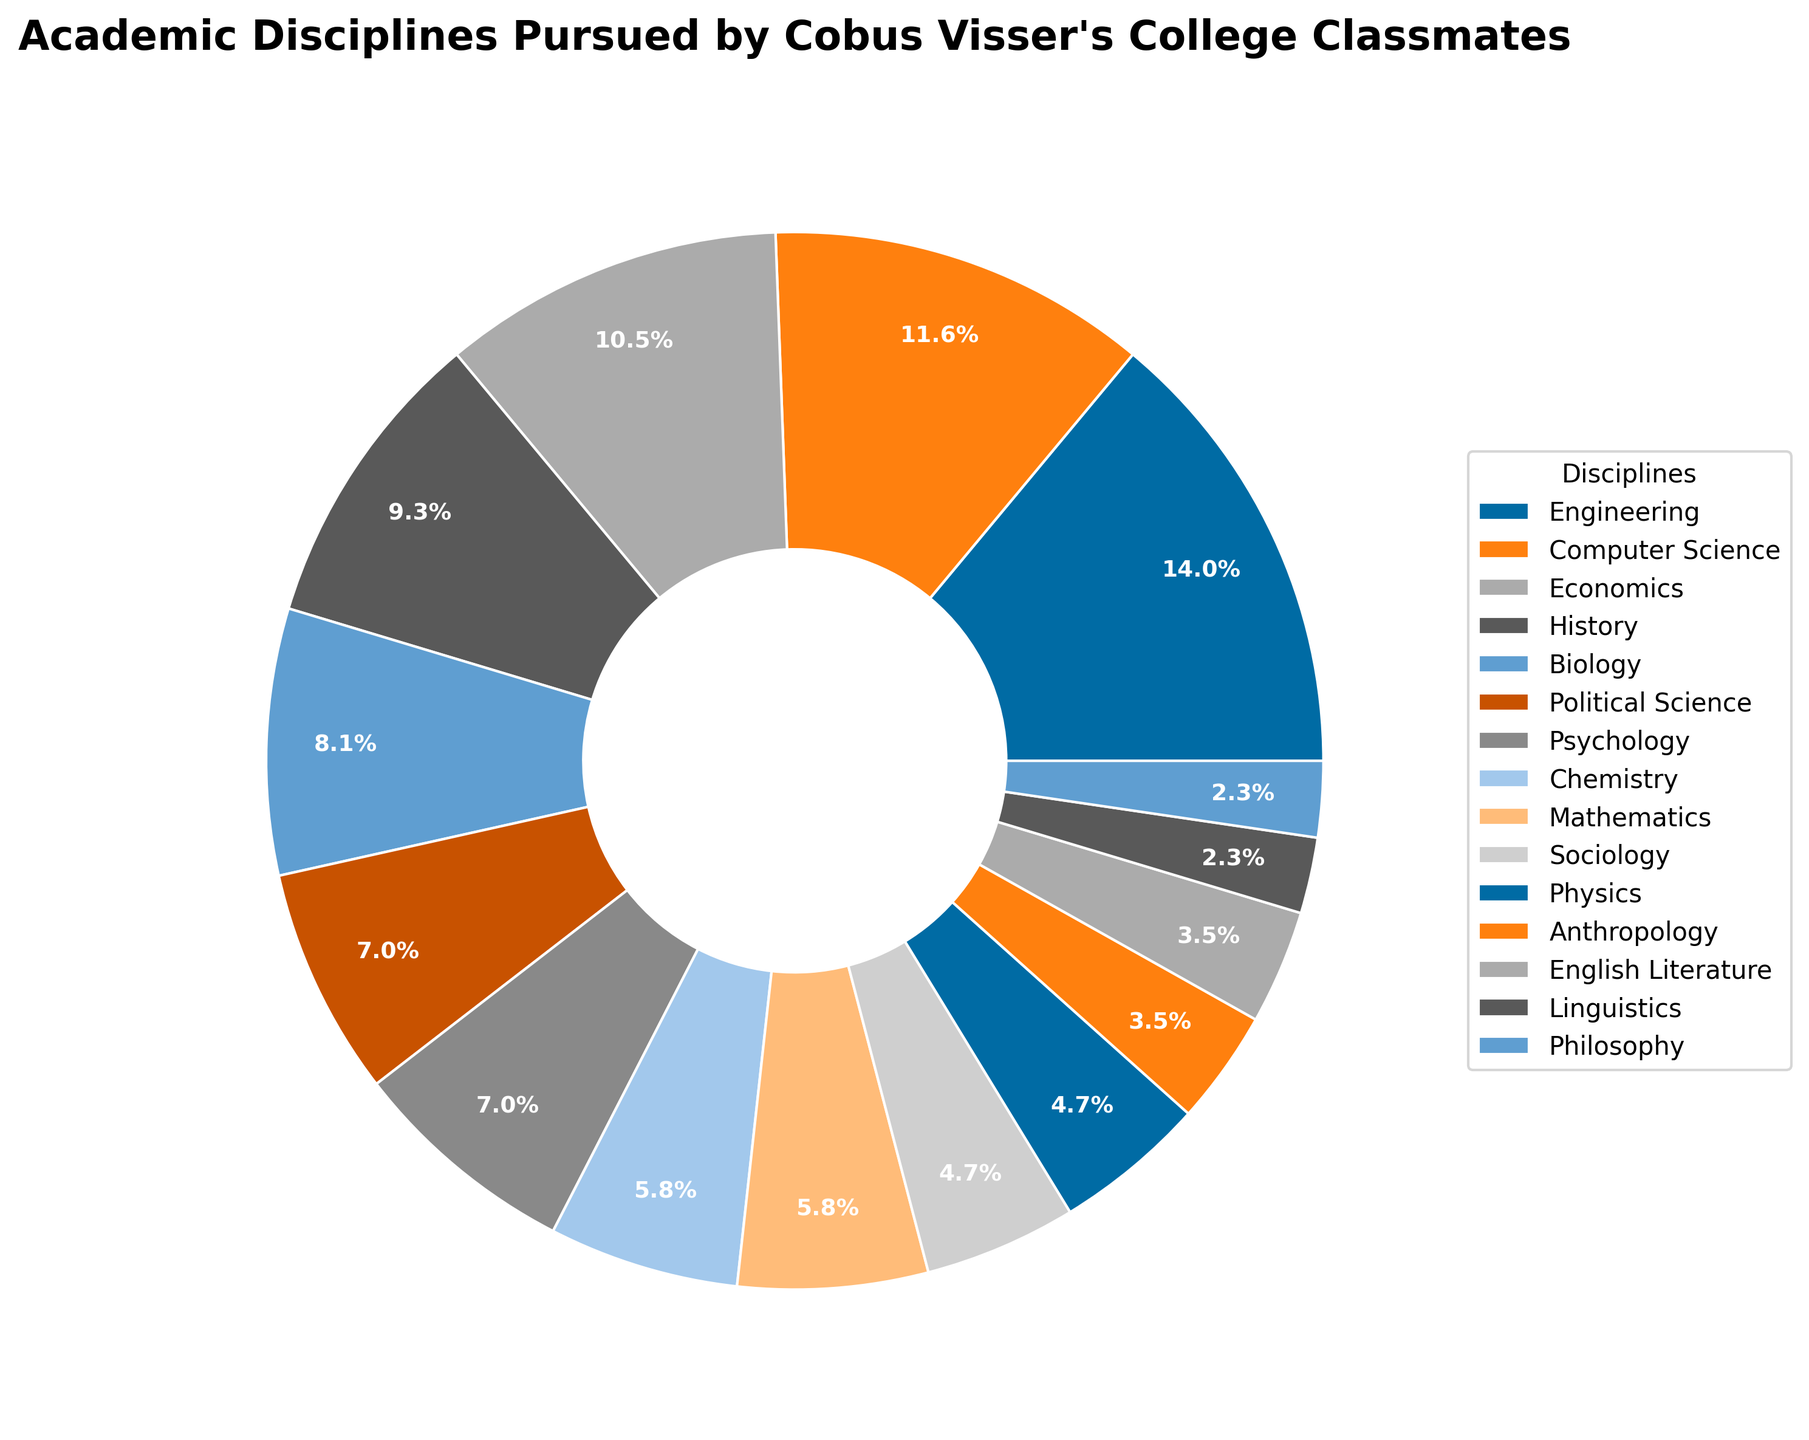What is the percentage of classmates who pursued Engineering? Refer to the pie chart's label for Engineering, which lists the percentage of classmates in that discipline.
Answer: 20.7% Which discipline has a smaller percentage of classmates: Biology or Sociology? Compare the percentages shown for Biology and Sociology in the pie chart. Biology has 12.1%, and Sociology has 6.9%.
Answer: Sociology How many disciplines have more than 10% of classmates? Identify the respective percentages from the pie chart and count those above 10%: Engineering, Computer Science, Economics, and History.
Answer: 4 What is the combined percentage of classmates in the Philosophy and Linguistics disciplines? Sum the percentages for Philosophy (3.4%) and Linguistics (3.4%) as shown in the pie chart. 3.4% + 3.4% = 6.8%.
Answer: 6.8% Which disciplines have the lowest and the highest percentages of classmates, respectively? Identify the disciplines with the lowest and highest percentages from the pie chart: Linguistics and Philosophy (both 3.4%) have the lowest, while Engineering (20.7%) has the highest.
Answer: Linguistics and Philosophy; Engineering Is the percentage of classmates in Political Science greater than those in Physics? Compare the percentages shown for Political Science (10.3%) and Physics (6.9%) in the pie chart.
Answer: Yes What is the difference in the percentage of classmates between the top two disciplines? Find the percentages for the top two disciplines in the pie chart: Engineering (20.7%) and Computer Science (17.2%). The difference is 20.7% - 17.2% = 3.5%.
Answer: 3.5% What is the most common academic discipline among Cobus Visser’s classmates? Look for the discipline with the largest percentage in the pie chart.
Answer: Engineering 